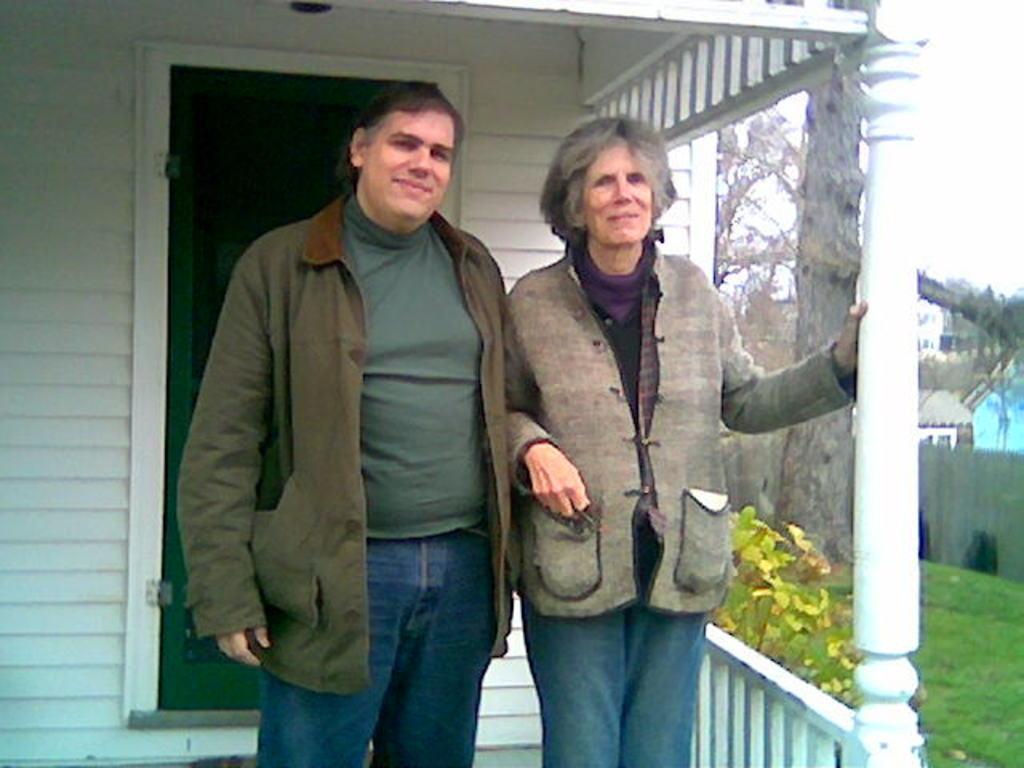How many people are in the image? There are two people in the image. What expressions do the people have? The people are smiling. What can be seen in the background of the image? There are buildings, trees, grass, and the sky visible in the background of the image. What type of detail can be seen on the frictionless surface in the image? There is no frictionless surface present in the image. How many rooms are visible in the image? The image does not show any rooms; it features two people and a background with buildings, trees, grass, and the sky. 